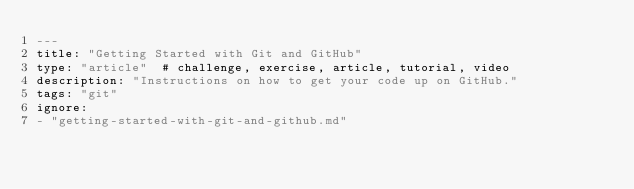Convert code to text. <code><loc_0><loc_0><loc_500><loc_500><_YAML_>---
title: "Getting Started with Git and GitHub"
type: "article"  # challenge, exercise, article, tutorial, video
description: "Instructions on how to get your code up on GitHub."
tags: "git"
ignore:
- "getting-started-with-git-and-github.md"
</code> 